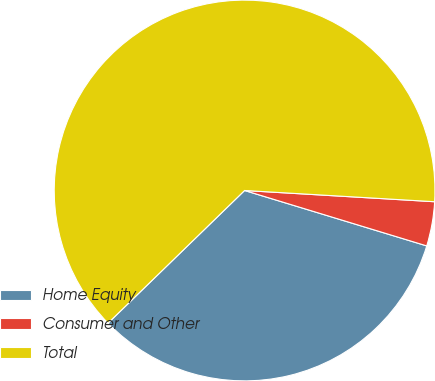<chart> <loc_0><loc_0><loc_500><loc_500><pie_chart><fcel>Home Equity<fcel>Consumer and Other<fcel>Total<nl><fcel>33.03%<fcel>3.76%<fcel>63.21%<nl></chart> 